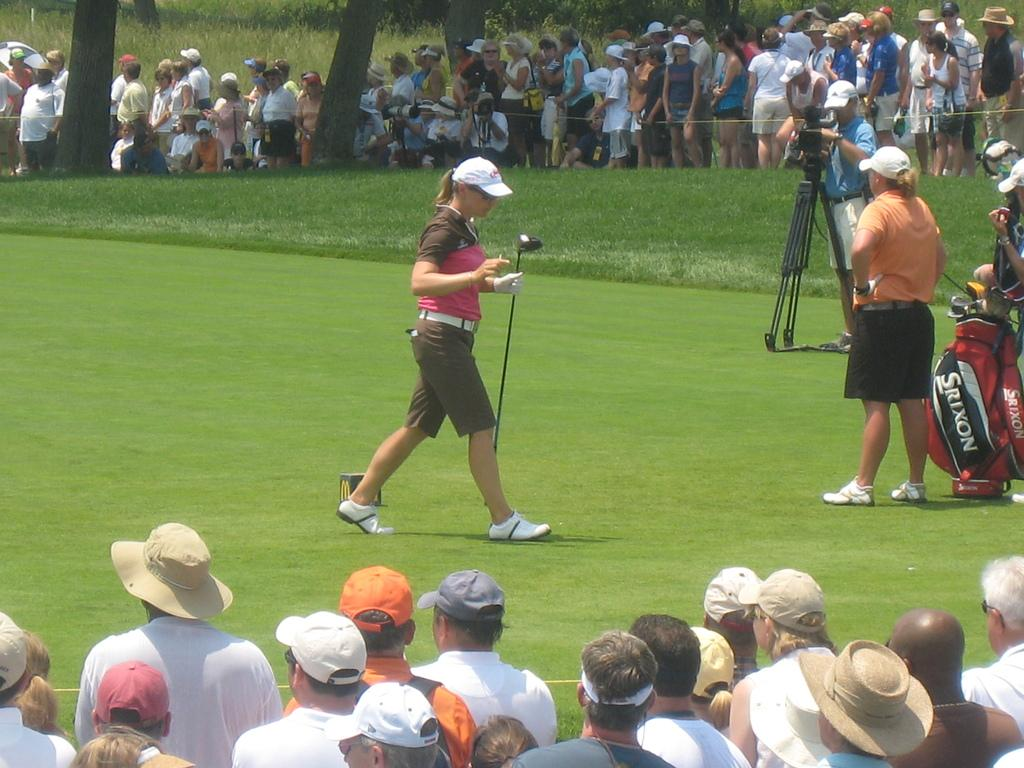Provide a one-sentence caption for the provided image. The golfer's red golf club bag is Srixon brand.. 